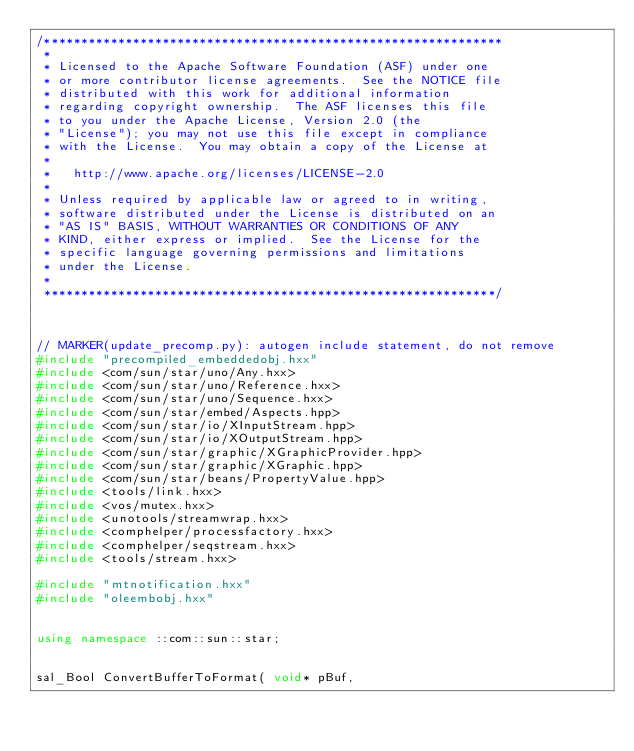Convert code to text. <code><loc_0><loc_0><loc_500><loc_500><_C++_>/**************************************************************
 * 
 * Licensed to the Apache Software Foundation (ASF) under one
 * or more contributor license agreements.  See the NOTICE file
 * distributed with this work for additional information
 * regarding copyright ownership.  The ASF licenses this file
 * to you under the Apache License, Version 2.0 (the
 * "License"); you may not use this file except in compliance
 * with the License.  You may obtain a copy of the License at
 * 
 *   http://www.apache.org/licenses/LICENSE-2.0
 * 
 * Unless required by applicable law or agreed to in writing,
 * software distributed under the License is distributed on an
 * "AS IS" BASIS, WITHOUT WARRANTIES OR CONDITIONS OF ANY
 * KIND, either express or implied.  See the License for the
 * specific language governing permissions and limitations
 * under the License.
 * 
 *************************************************************/



// MARKER(update_precomp.py): autogen include statement, do not remove
#include "precompiled_embeddedobj.hxx"
#include <com/sun/star/uno/Any.hxx>
#include <com/sun/star/uno/Reference.hxx>
#include <com/sun/star/uno/Sequence.hxx>
#include <com/sun/star/embed/Aspects.hpp>
#include <com/sun/star/io/XInputStream.hpp>
#include <com/sun/star/io/XOutputStream.hpp>
#include <com/sun/star/graphic/XGraphicProvider.hpp>
#include <com/sun/star/graphic/XGraphic.hpp>
#include <com/sun/star/beans/PropertyValue.hpp>
#include <tools/link.hxx>
#include <vos/mutex.hxx>
#include <unotools/streamwrap.hxx>
#include <comphelper/processfactory.hxx>
#include <comphelper/seqstream.hxx>
#include <tools/stream.hxx>

#include "mtnotification.hxx"
#include "oleembobj.hxx"


using namespace ::com::sun::star;

			
sal_Bool ConvertBufferToFormat( void* pBuf,</code> 